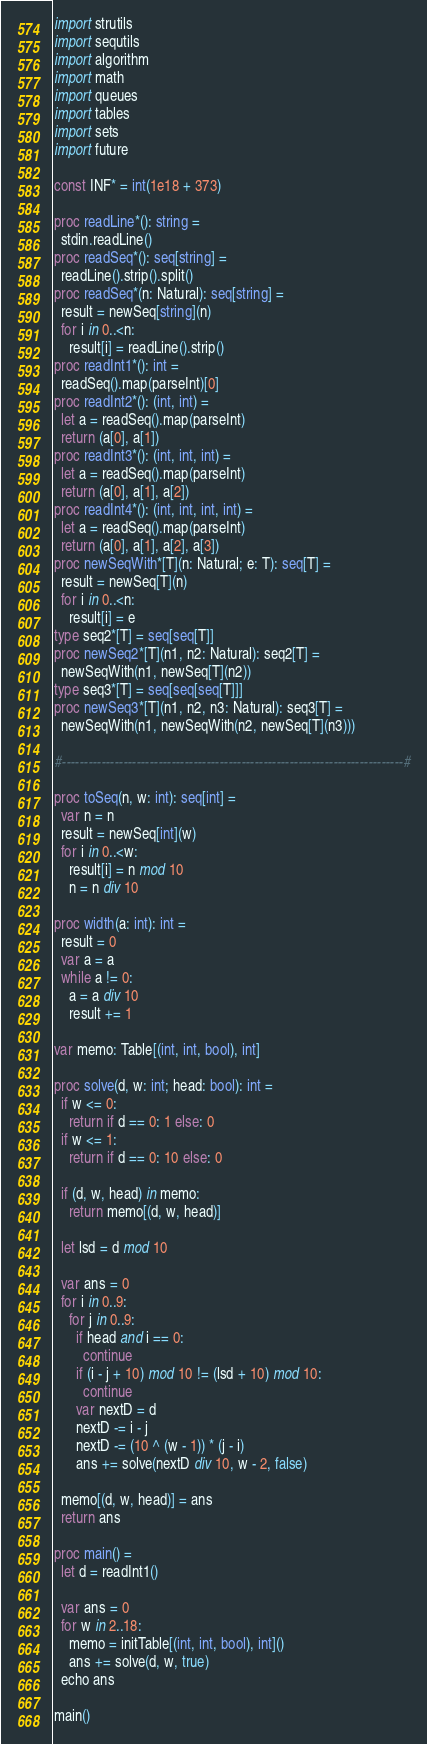<code> <loc_0><loc_0><loc_500><loc_500><_Nim_>import strutils
import sequtils
import algorithm
import math
import queues
import tables
import sets
import future

const INF* = int(1e18 + 373)

proc readLine*(): string =
  stdin.readLine()
proc readSeq*(): seq[string] =
  readLine().strip().split()
proc readSeq*(n: Natural): seq[string] =
  result = newSeq[string](n)
  for i in 0..<n:
    result[i] = readLine().strip()
proc readInt1*(): int =
  readSeq().map(parseInt)[0]
proc readInt2*(): (int, int) =
  let a = readSeq().map(parseInt)
  return (a[0], a[1])
proc readInt3*(): (int, int, int) =
  let a = readSeq().map(parseInt)
  return (a[0], a[1], a[2])
proc readInt4*(): (int, int, int, int) =
  let a = readSeq().map(parseInt)
  return (a[0], a[1], a[2], a[3])
proc newSeqWith*[T](n: Natural; e: T): seq[T] =
  result = newSeq[T](n)
  for i in 0..<n:
    result[i] = e
type seq2*[T] = seq[seq[T]]
proc newSeq2*[T](n1, n2: Natural): seq2[T] =
  newSeqWith(n1, newSeq[T](n2))
type seq3*[T] = seq[seq[seq[T]]]
proc newSeq3*[T](n1, n2, n3: Natural): seq3[T] =
  newSeqWith(n1, newSeqWith(n2, newSeq[T](n3)))

#------------------------------------------------------------------------------#

proc toSeq(n, w: int): seq[int] =
  var n = n
  result = newSeq[int](w)
  for i in 0..<w:
    result[i] = n mod 10
    n = n div 10

proc width(a: int): int =
  result = 0
  var a = a
  while a != 0:
    a = a div 10
    result += 1

var memo: Table[(int, int, bool), int]

proc solve(d, w: int; head: bool): int =
  if w <= 0:
    return if d == 0: 1 else: 0
  if w <= 1:
    return if d == 0: 10 else: 0

  if (d, w, head) in memo:
    return memo[(d, w, head)]

  let lsd = d mod 10

  var ans = 0
  for i in 0..9:
    for j in 0..9:
      if head and i == 0:
        continue
      if (i - j + 10) mod 10 != (lsd + 10) mod 10:
        continue
      var nextD = d
      nextD -= i - j
      nextD -= (10 ^ (w - 1)) * (j - i)
      ans += solve(nextD div 10, w - 2, false)

  memo[(d, w, head)] = ans
  return ans

proc main() =
  let d = readInt1()

  var ans = 0
  for w in 2..18:
    memo = initTable[(int, int, bool), int]()
    ans += solve(d, w, true)
  echo ans

main()

</code> 